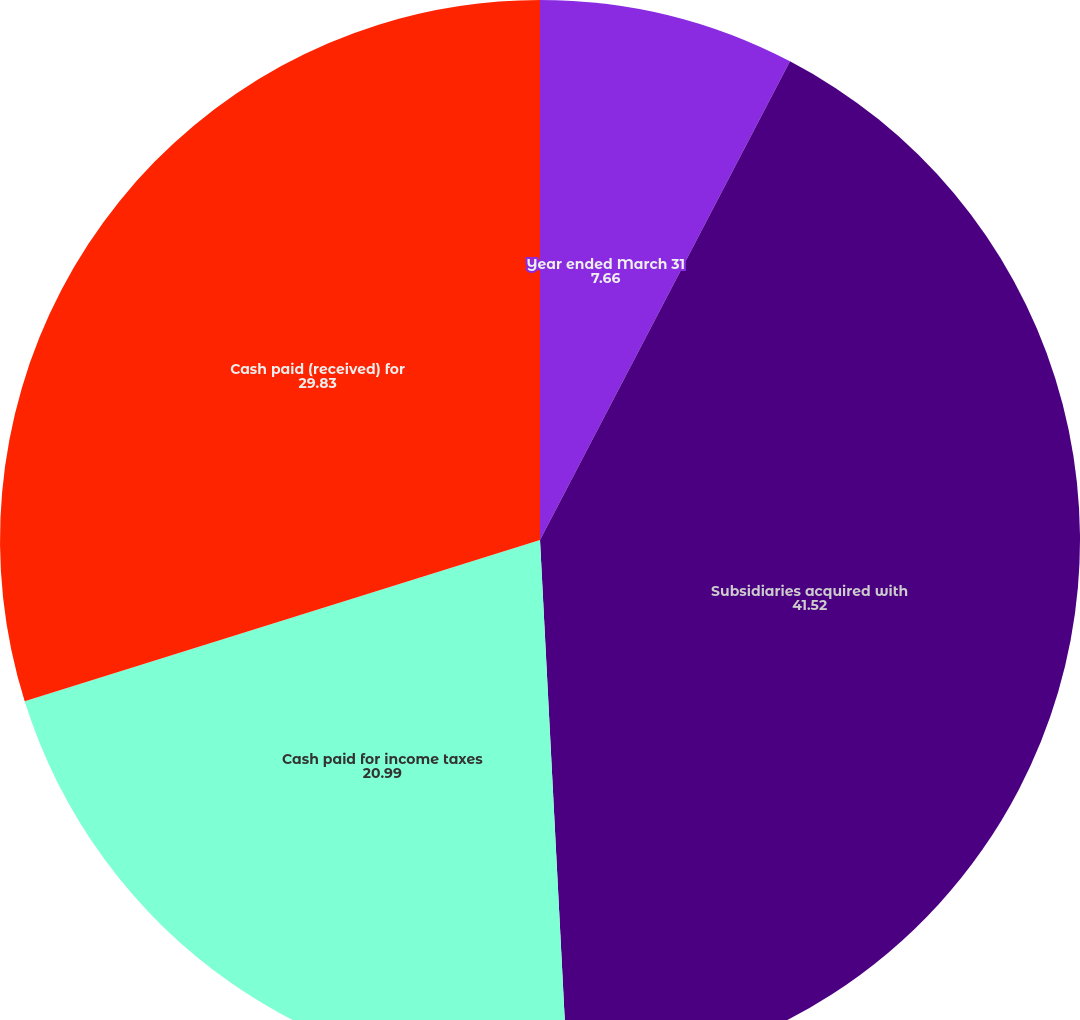Convert chart to OTSL. <chart><loc_0><loc_0><loc_500><loc_500><pie_chart><fcel>Year ended March 31<fcel>Subsidiaries acquired with<fcel>Cash paid for income taxes<fcel>Cash paid (received) for<nl><fcel>7.66%<fcel>41.52%<fcel>20.99%<fcel>29.83%<nl></chart> 